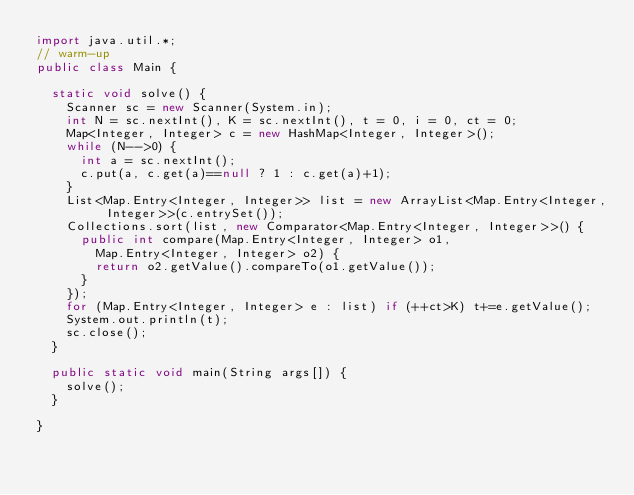<code> <loc_0><loc_0><loc_500><loc_500><_Java_>import java.util.*;
// warm-up
public class Main {

	static void solve() {
		Scanner sc = new Scanner(System.in);
		int N = sc.nextInt(), K = sc.nextInt(), t = 0, i = 0, ct = 0;
		Map<Integer, Integer> c = new HashMap<Integer, Integer>();
		while (N-->0) {
			int a = sc.nextInt();
			c.put(a, c.get(a)==null ? 1 : c.get(a)+1);
		}
		List<Map.Entry<Integer, Integer>> list = new ArrayList<Map.Entry<Integer, Integer>>(c.entrySet());
		Collections.sort(list, new Comparator<Map.Entry<Integer, Integer>>() {
			public int compare(Map.Entry<Integer, Integer> o1,
				Map.Entry<Integer, Integer> o2) {
				return o2.getValue().compareTo(o1.getValue());
			}
		});
		for (Map.Entry<Integer, Integer> e : list) if (++ct>K) t+=e.getValue();
		System.out.println(t);
		sc.close();		
	}

	public static void main(String args[]) {
		solve();
	}

}</code> 